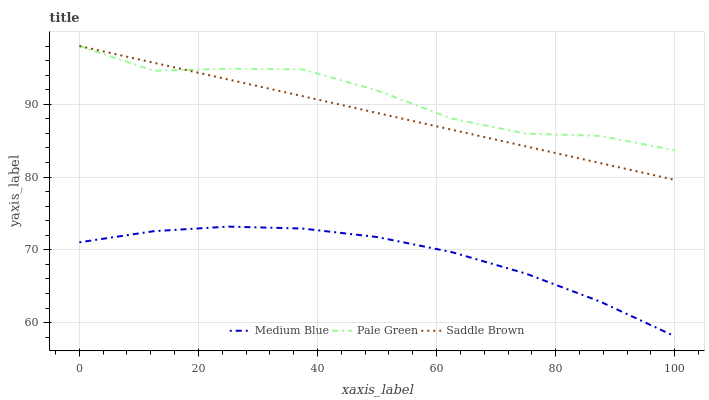Does Medium Blue have the minimum area under the curve?
Answer yes or no. Yes. Does Pale Green have the maximum area under the curve?
Answer yes or no. Yes. Does Saddle Brown have the minimum area under the curve?
Answer yes or no. No. Does Saddle Brown have the maximum area under the curve?
Answer yes or no. No. Is Saddle Brown the smoothest?
Answer yes or no. Yes. Is Pale Green the roughest?
Answer yes or no. Yes. Is Medium Blue the smoothest?
Answer yes or no. No. Is Medium Blue the roughest?
Answer yes or no. No. Does Medium Blue have the lowest value?
Answer yes or no. Yes. Does Saddle Brown have the lowest value?
Answer yes or no. No. Does Saddle Brown have the highest value?
Answer yes or no. Yes. Does Medium Blue have the highest value?
Answer yes or no. No. Is Medium Blue less than Saddle Brown?
Answer yes or no. Yes. Is Pale Green greater than Medium Blue?
Answer yes or no. Yes. Does Pale Green intersect Saddle Brown?
Answer yes or no. Yes. Is Pale Green less than Saddle Brown?
Answer yes or no. No. Is Pale Green greater than Saddle Brown?
Answer yes or no. No. Does Medium Blue intersect Saddle Brown?
Answer yes or no. No. 